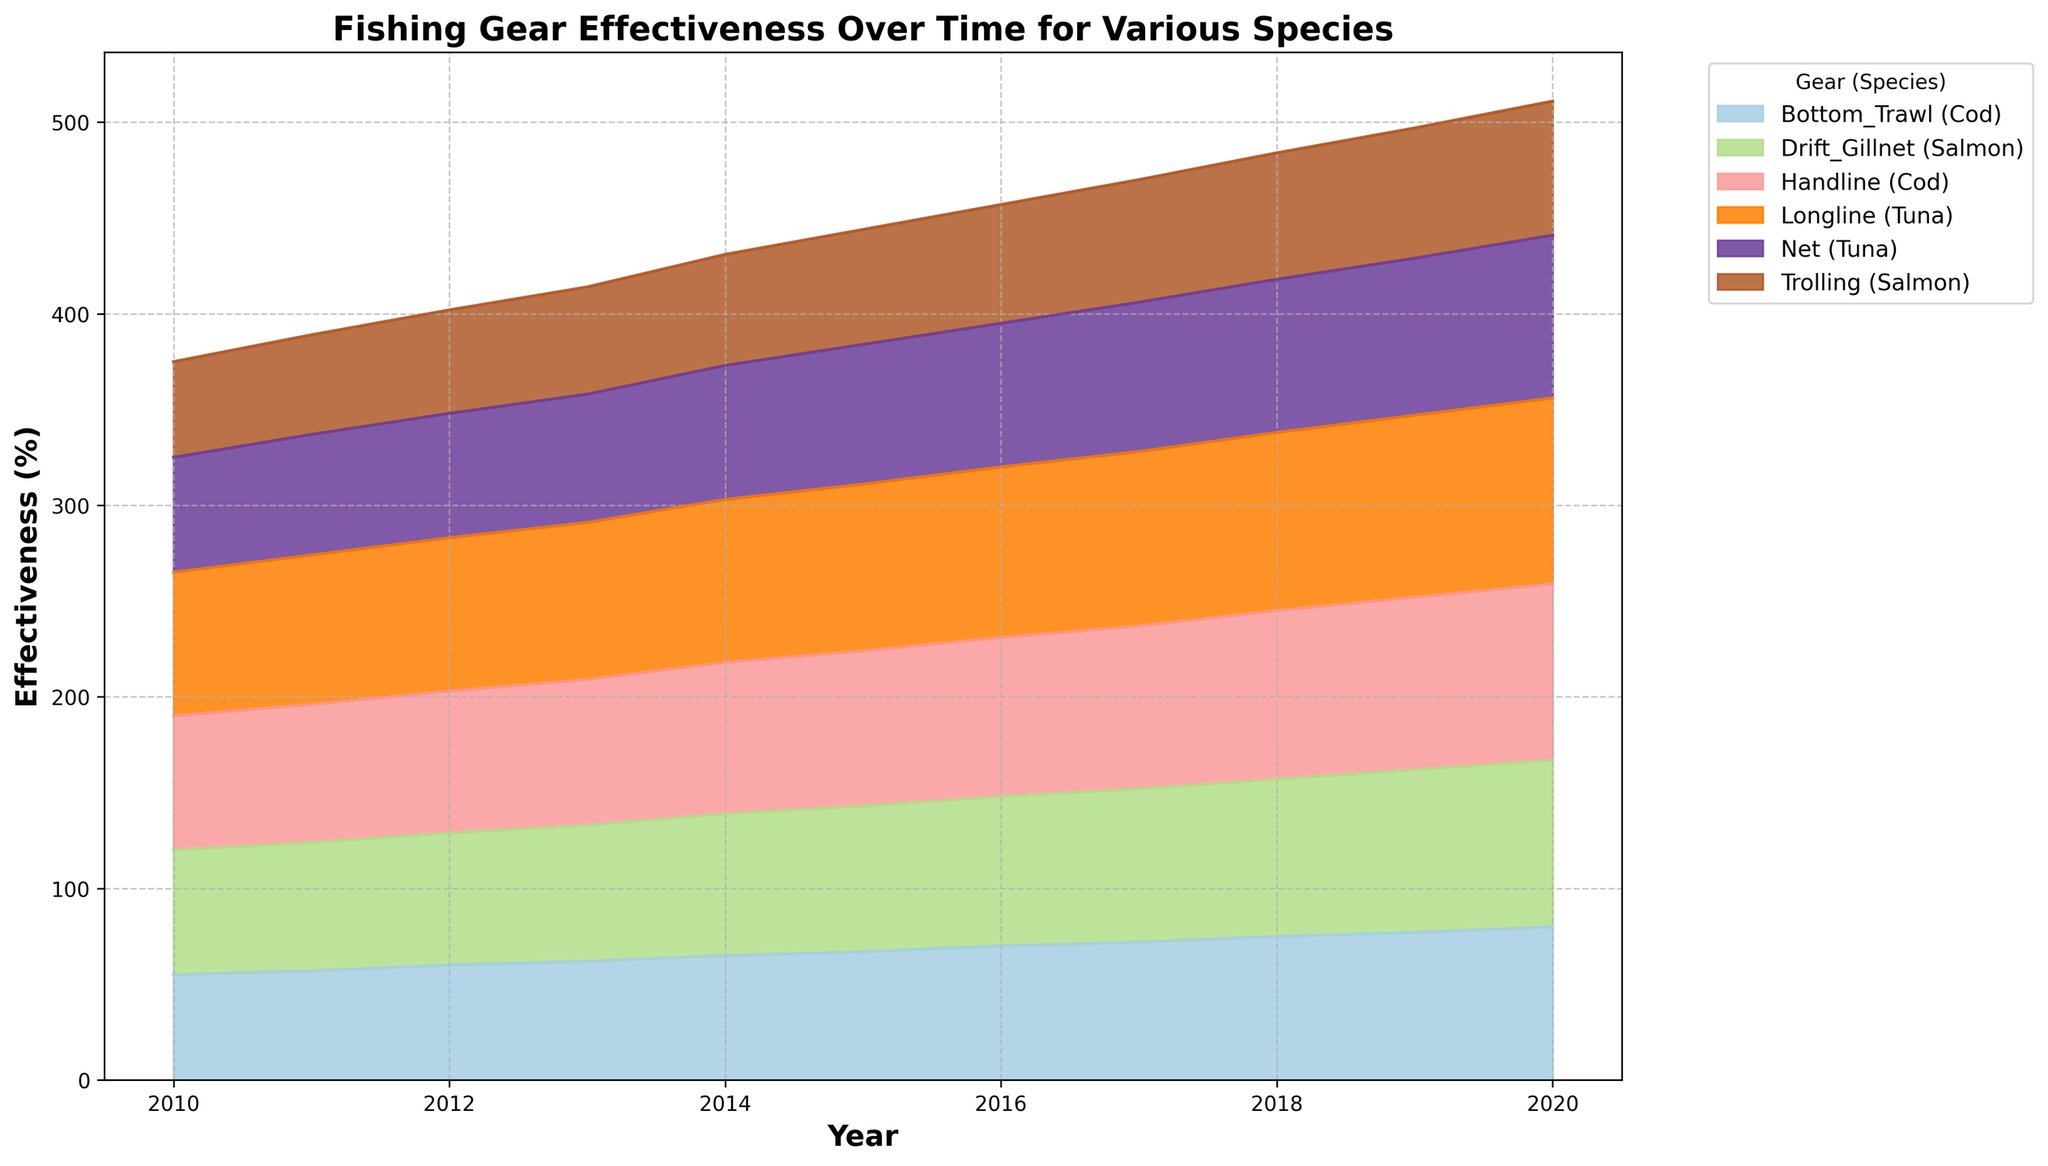How did the effectiveness of Longline for Tuna change from 2010 to 2020? The effectiveness of Longline for Tuna starts at 75% in 2010 and increases each year. By 2020, it reaches 97%. The change can be seen as a steady increase over time.
Answer: It increased Which gear type for Cod was more effective in 2015, Bottom_Trawl or Handline? In 2015, the effectiveness for Bottom_Trawl was at 67% and for Handline it was at 81%. By comparing these values, we can see that Handline was more effective.
Answer: Handline What was the average effectiveness of all Tuna gear combined in 2012? The effectiveness of Longline for Tuna in 2012 is 80%, and for Net, it is 65%. To find the average, we sum them (80 + 65 = 145) and divide by 2 (145 / 2 = 72.5).
Answer: 72.5% Among all listed species and gears, which showed the highest effectiveness in 2019? By scanning the visual representation for 2019, Handline for Cod shows the highest effectiveness with 90%.
Answer: Handline (Cod) Between Trolling and Drift_Gillnet, which gear showed a greater increase in effectiveness for Salmon from 2010 to 2018? Trolling increased from 50% in 2010 to 66% in 2018 (a change of 16%). Drift_Gillnet increased from 65% to 82% in the same period (a change of 17%). Drift_Gillnet showed a greater increase.
Answer: Drift_Gillnet Did any gear for any species show a consistent improvement in effectiveness every year from 2010 to 2020? Observing the chart, Longline for Tuna shows consistent improvement every year from 75% in 2010 to 97% in 2020.
Answer: Yes, Longline (Tuna) How much more effective was the Drift_Gillnet for Salmon than Trolling in 2020? The effectiveness for Drift_Gillnet in 2020 is 87% and for Trolling it is 70%. The difference is 87 - 70 = 17%.
Answer: 17% Which gear type and species combination had the lowest effectiveness in 2014? In 2014, Trolling for Salmon shows the lowest effectiveness with 58%.
Answer: Trolling (Salmon) What is the trend for Net effectiveness for Tuna from 2010 to 2020? The effectiveness of Net for Tuna shows an upward trend. It increases from 60% in 2010 to 85% in 2020.
Answer: Increasing Compare the effectiveness of Bottom_Trawl for Cod in 2013 and 2018. Which year had higher effectiveness? Effectiveness in 2013 for Bottom_Trawl (Cod) is 62%, whereas in 2018, it is 75%. Comparing these values, 2018 had a higher effectiveness.
Answer: 2018 